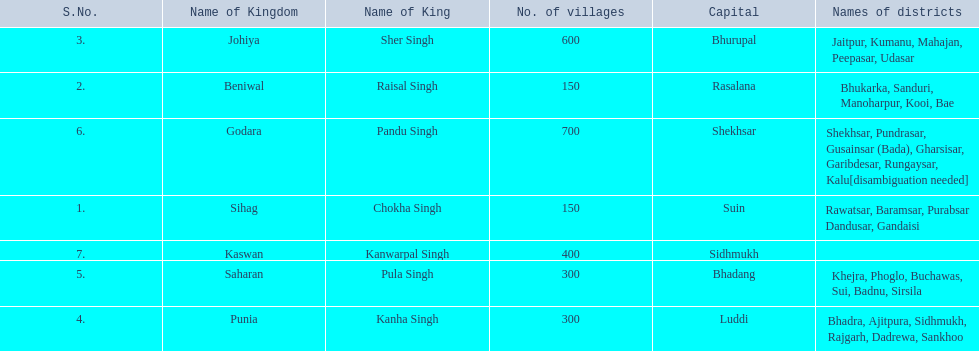Which kingdom contained the second most villages, next only to godara? Johiya. 